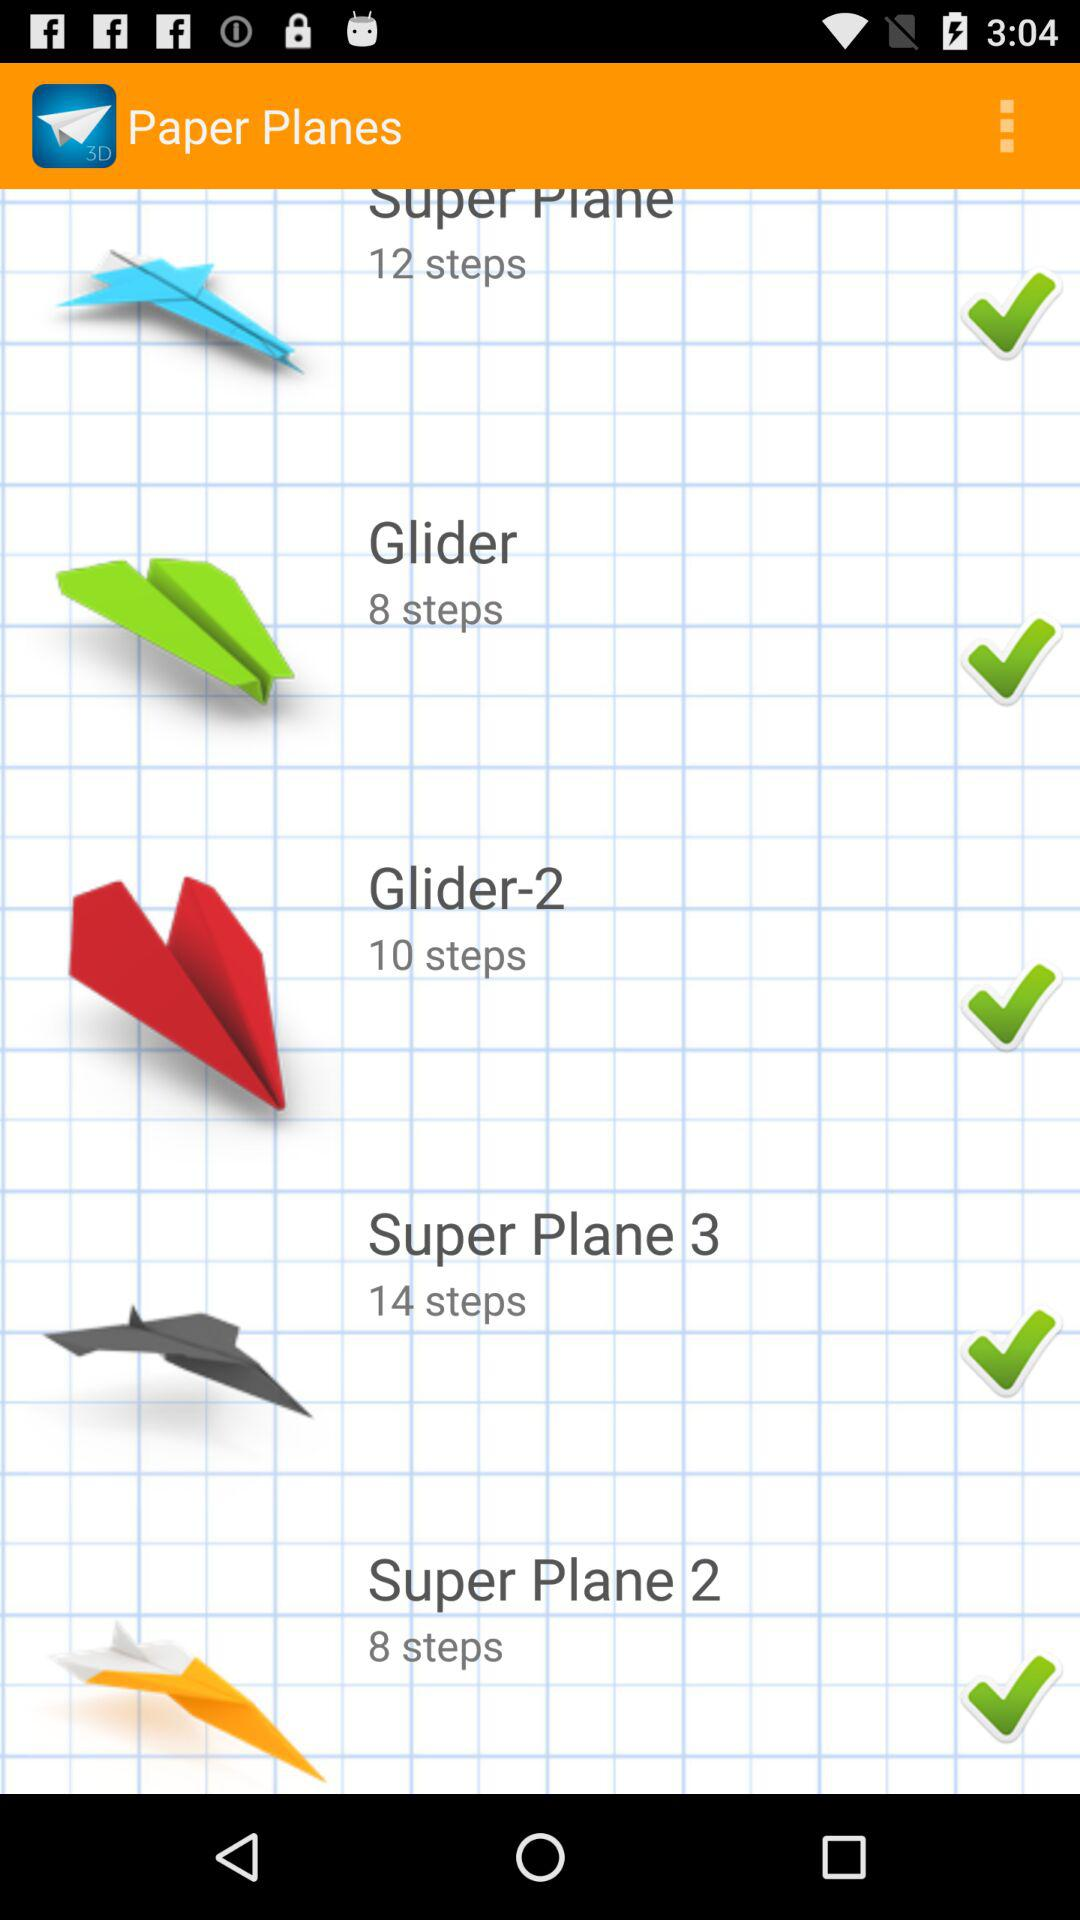How many steps have been counted in making glider paper planes? The number of steps in making glider paper planes is 8. 